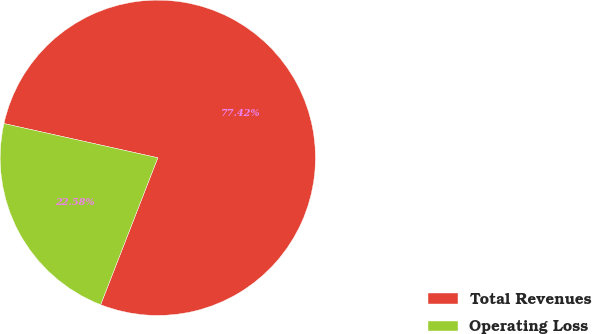Convert chart to OTSL. <chart><loc_0><loc_0><loc_500><loc_500><pie_chart><fcel>Total Revenues<fcel>Operating Loss<nl><fcel>77.42%<fcel>22.58%<nl></chart> 